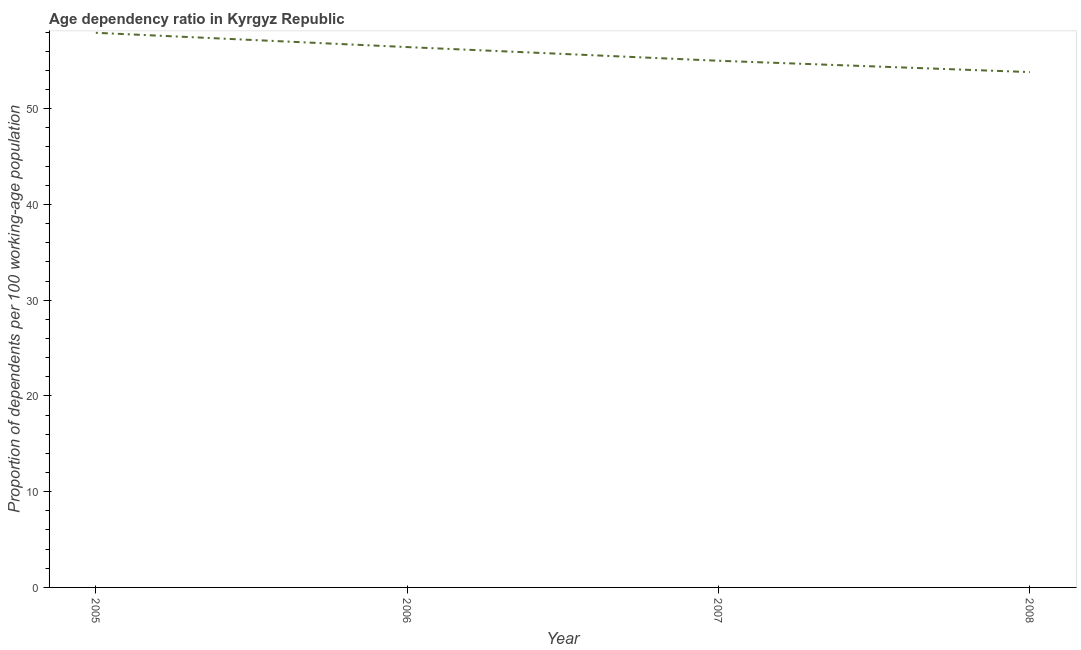What is the age dependency ratio in 2008?
Provide a short and direct response. 53.82. Across all years, what is the maximum age dependency ratio?
Ensure brevity in your answer.  57.92. Across all years, what is the minimum age dependency ratio?
Your response must be concise. 53.82. In which year was the age dependency ratio minimum?
Make the answer very short. 2008. What is the sum of the age dependency ratio?
Provide a succinct answer. 223.17. What is the difference between the age dependency ratio in 2007 and 2008?
Keep it short and to the point. 1.18. What is the average age dependency ratio per year?
Provide a succinct answer. 55.79. What is the median age dependency ratio?
Offer a terse response. 55.72. In how many years, is the age dependency ratio greater than 36 ?
Give a very brief answer. 4. Do a majority of the years between 2005 and 2008 (inclusive) have age dependency ratio greater than 50 ?
Give a very brief answer. Yes. What is the ratio of the age dependency ratio in 2007 to that in 2008?
Give a very brief answer. 1.02. Is the age dependency ratio in 2005 less than that in 2006?
Provide a short and direct response. No. Is the difference between the age dependency ratio in 2005 and 2008 greater than the difference between any two years?
Offer a very short reply. Yes. What is the difference between the highest and the second highest age dependency ratio?
Keep it short and to the point. 1.49. What is the difference between the highest and the lowest age dependency ratio?
Your response must be concise. 4.1. How many years are there in the graph?
Offer a terse response. 4. What is the difference between two consecutive major ticks on the Y-axis?
Give a very brief answer. 10. What is the title of the graph?
Your answer should be very brief. Age dependency ratio in Kyrgyz Republic. What is the label or title of the X-axis?
Keep it short and to the point. Year. What is the label or title of the Y-axis?
Offer a terse response. Proportion of dependents per 100 working-age population. What is the Proportion of dependents per 100 working-age population in 2005?
Your response must be concise. 57.92. What is the Proportion of dependents per 100 working-age population in 2006?
Give a very brief answer. 56.43. What is the Proportion of dependents per 100 working-age population of 2007?
Your response must be concise. 55. What is the Proportion of dependents per 100 working-age population of 2008?
Your response must be concise. 53.82. What is the difference between the Proportion of dependents per 100 working-age population in 2005 and 2006?
Your answer should be very brief. 1.49. What is the difference between the Proportion of dependents per 100 working-age population in 2005 and 2007?
Your answer should be compact. 2.92. What is the difference between the Proportion of dependents per 100 working-age population in 2005 and 2008?
Keep it short and to the point. 4.1. What is the difference between the Proportion of dependents per 100 working-age population in 2006 and 2007?
Offer a very short reply. 1.43. What is the difference between the Proportion of dependents per 100 working-age population in 2006 and 2008?
Make the answer very short. 2.61. What is the difference between the Proportion of dependents per 100 working-age population in 2007 and 2008?
Offer a very short reply. 1.18. What is the ratio of the Proportion of dependents per 100 working-age population in 2005 to that in 2007?
Offer a very short reply. 1.05. What is the ratio of the Proportion of dependents per 100 working-age population in 2005 to that in 2008?
Provide a short and direct response. 1.08. What is the ratio of the Proportion of dependents per 100 working-age population in 2006 to that in 2008?
Offer a terse response. 1.05. What is the ratio of the Proportion of dependents per 100 working-age population in 2007 to that in 2008?
Offer a very short reply. 1.02. 